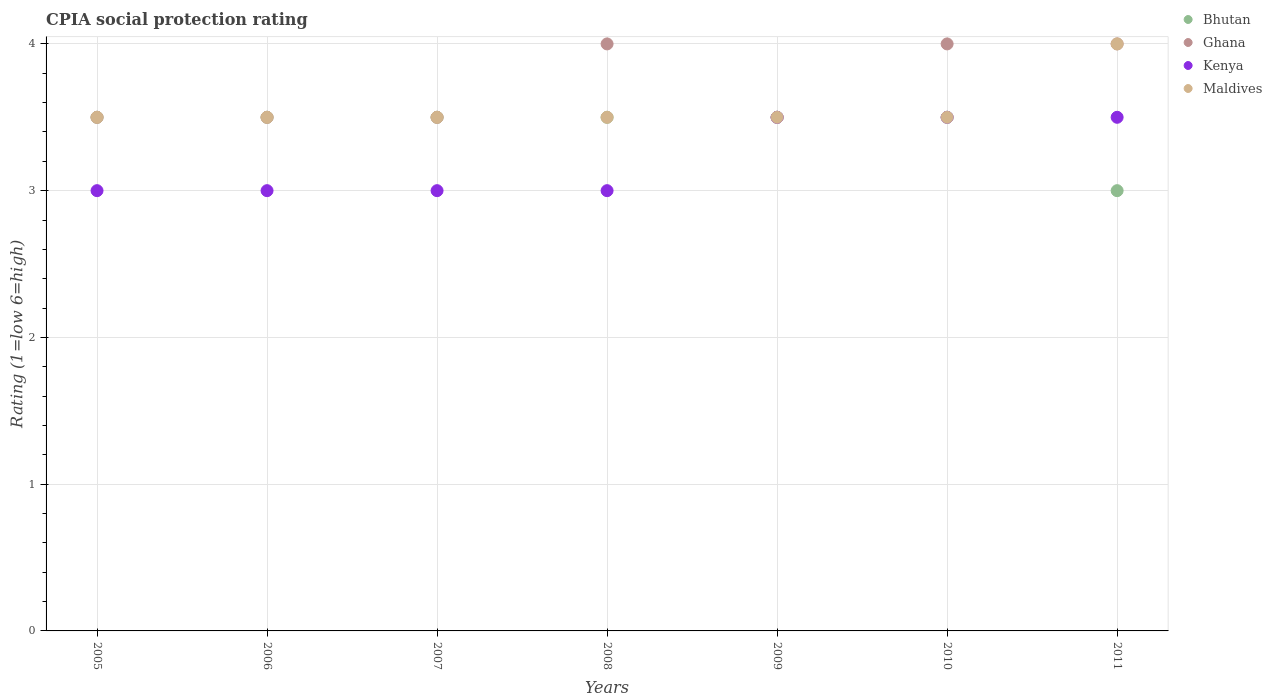What is the CPIA rating in Maldives in 2010?
Make the answer very short. 3.5. Across all years, what is the minimum CPIA rating in Kenya?
Ensure brevity in your answer.  3. What is the total CPIA rating in Maldives in the graph?
Offer a very short reply. 25. What is the average CPIA rating in Kenya per year?
Your answer should be compact. 3.21. What is the ratio of the CPIA rating in Ghana in 2010 to that in 2011?
Ensure brevity in your answer.  1. Is the difference between the CPIA rating in Ghana in 2005 and 2006 greater than the difference between the CPIA rating in Bhutan in 2005 and 2006?
Keep it short and to the point. No. Is the sum of the CPIA rating in Ghana in 2008 and 2009 greater than the maximum CPIA rating in Bhutan across all years?
Your answer should be very brief. Yes. Is it the case that in every year, the sum of the CPIA rating in Maldives and CPIA rating in Kenya  is greater than the CPIA rating in Ghana?
Ensure brevity in your answer.  Yes. Is the CPIA rating in Ghana strictly less than the CPIA rating in Maldives over the years?
Provide a succinct answer. No. What is the difference between two consecutive major ticks on the Y-axis?
Ensure brevity in your answer.  1. Are the values on the major ticks of Y-axis written in scientific E-notation?
Keep it short and to the point. No. Does the graph contain any zero values?
Provide a short and direct response. No. Does the graph contain grids?
Provide a succinct answer. Yes. Where does the legend appear in the graph?
Your response must be concise. Top right. How are the legend labels stacked?
Give a very brief answer. Vertical. What is the title of the graph?
Ensure brevity in your answer.  CPIA social protection rating. Does "Venezuela" appear as one of the legend labels in the graph?
Provide a succinct answer. No. What is the label or title of the X-axis?
Your answer should be very brief. Years. What is the Rating (1=low 6=high) of Bhutan in 2005?
Your answer should be very brief. 3.5. What is the Rating (1=low 6=high) in Ghana in 2005?
Ensure brevity in your answer.  3.5. What is the Rating (1=low 6=high) of Kenya in 2005?
Ensure brevity in your answer.  3. What is the Rating (1=low 6=high) of Maldives in 2005?
Provide a short and direct response. 3.5. What is the Rating (1=low 6=high) of Ghana in 2006?
Offer a terse response. 3.5. What is the Rating (1=low 6=high) in Kenya in 2006?
Provide a short and direct response. 3. What is the Rating (1=low 6=high) in Maldives in 2006?
Keep it short and to the point. 3.5. What is the Rating (1=low 6=high) of Bhutan in 2007?
Ensure brevity in your answer.  3.5. What is the Rating (1=low 6=high) of Ghana in 2007?
Provide a succinct answer. 3.5. What is the Rating (1=low 6=high) of Maldives in 2008?
Offer a very short reply. 3.5. What is the Rating (1=low 6=high) of Bhutan in 2009?
Provide a succinct answer. 3.5. What is the Rating (1=low 6=high) in Ghana in 2009?
Provide a succinct answer. 3.5. What is the Rating (1=low 6=high) of Maldives in 2009?
Your answer should be compact. 3.5. What is the Rating (1=low 6=high) of Bhutan in 2010?
Make the answer very short. 3.5. What is the Rating (1=low 6=high) of Maldives in 2010?
Provide a succinct answer. 3.5. What is the Rating (1=low 6=high) in Ghana in 2011?
Provide a succinct answer. 4. What is the Rating (1=low 6=high) of Kenya in 2011?
Give a very brief answer. 3.5. Across all years, what is the maximum Rating (1=low 6=high) of Ghana?
Offer a very short reply. 4. Across all years, what is the maximum Rating (1=low 6=high) in Kenya?
Your response must be concise. 3.5. Across all years, what is the maximum Rating (1=low 6=high) in Maldives?
Keep it short and to the point. 4. Across all years, what is the minimum Rating (1=low 6=high) in Bhutan?
Your response must be concise. 3. Across all years, what is the minimum Rating (1=low 6=high) in Kenya?
Provide a succinct answer. 3. What is the total Rating (1=low 6=high) of Bhutan in the graph?
Offer a terse response. 24. What is the total Rating (1=low 6=high) in Ghana in the graph?
Keep it short and to the point. 26. What is the total Rating (1=low 6=high) in Kenya in the graph?
Offer a very short reply. 22.5. What is the difference between the Rating (1=low 6=high) of Ghana in 2005 and that in 2006?
Offer a terse response. 0. What is the difference between the Rating (1=low 6=high) of Maldives in 2005 and that in 2006?
Your answer should be compact. 0. What is the difference between the Rating (1=low 6=high) in Bhutan in 2005 and that in 2007?
Ensure brevity in your answer.  0. What is the difference between the Rating (1=low 6=high) of Ghana in 2005 and that in 2007?
Your answer should be very brief. 0. What is the difference between the Rating (1=low 6=high) of Kenya in 2005 and that in 2007?
Offer a very short reply. 0. What is the difference between the Rating (1=low 6=high) of Maldives in 2005 and that in 2007?
Give a very brief answer. 0. What is the difference between the Rating (1=low 6=high) of Ghana in 2005 and that in 2008?
Provide a short and direct response. -0.5. What is the difference between the Rating (1=low 6=high) in Maldives in 2005 and that in 2008?
Make the answer very short. 0. What is the difference between the Rating (1=low 6=high) in Maldives in 2005 and that in 2009?
Your answer should be very brief. 0. What is the difference between the Rating (1=low 6=high) of Bhutan in 2005 and that in 2010?
Your answer should be very brief. 0. What is the difference between the Rating (1=low 6=high) of Ghana in 2005 and that in 2010?
Your response must be concise. -0.5. What is the difference between the Rating (1=low 6=high) of Ghana in 2005 and that in 2011?
Offer a terse response. -0.5. What is the difference between the Rating (1=low 6=high) of Kenya in 2005 and that in 2011?
Keep it short and to the point. -0.5. What is the difference between the Rating (1=low 6=high) of Bhutan in 2006 and that in 2008?
Your response must be concise. 0. What is the difference between the Rating (1=low 6=high) in Kenya in 2006 and that in 2008?
Keep it short and to the point. 0. What is the difference between the Rating (1=low 6=high) in Bhutan in 2006 and that in 2009?
Provide a short and direct response. 0. What is the difference between the Rating (1=low 6=high) of Ghana in 2006 and that in 2009?
Offer a terse response. 0. What is the difference between the Rating (1=low 6=high) of Kenya in 2006 and that in 2009?
Offer a terse response. -0.5. What is the difference between the Rating (1=low 6=high) in Kenya in 2006 and that in 2010?
Offer a terse response. -0.5. What is the difference between the Rating (1=low 6=high) in Kenya in 2006 and that in 2011?
Ensure brevity in your answer.  -0.5. What is the difference between the Rating (1=low 6=high) of Maldives in 2006 and that in 2011?
Provide a short and direct response. -0.5. What is the difference between the Rating (1=low 6=high) in Bhutan in 2007 and that in 2008?
Give a very brief answer. 0. What is the difference between the Rating (1=low 6=high) of Ghana in 2007 and that in 2008?
Make the answer very short. -0.5. What is the difference between the Rating (1=low 6=high) of Bhutan in 2007 and that in 2009?
Your answer should be very brief. 0. What is the difference between the Rating (1=low 6=high) in Kenya in 2007 and that in 2009?
Provide a succinct answer. -0.5. What is the difference between the Rating (1=low 6=high) in Ghana in 2007 and that in 2010?
Keep it short and to the point. -0.5. What is the difference between the Rating (1=low 6=high) in Kenya in 2007 and that in 2010?
Offer a terse response. -0.5. What is the difference between the Rating (1=low 6=high) of Bhutan in 2007 and that in 2011?
Keep it short and to the point. 0.5. What is the difference between the Rating (1=low 6=high) of Kenya in 2007 and that in 2011?
Your answer should be compact. -0.5. What is the difference between the Rating (1=low 6=high) of Bhutan in 2008 and that in 2009?
Provide a succinct answer. 0. What is the difference between the Rating (1=low 6=high) in Kenya in 2008 and that in 2009?
Keep it short and to the point. -0.5. What is the difference between the Rating (1=low 6=high) in Ghana in 2008 and that in 2010?
Provide a short and direct response. 0. What is the difference between the Rating (1=low 6=high) in Maldives in 2009 and that in 2010?
Offer a very short reply. 0. What is the difference between the Rating (1=low 6=high) of Bhutan in 2009 and that in 2011?
Keep it short and to the point. 0.5. What is the difference between the Rating (1=low 6=high) of Kenya in 2009 and that in 2011?
Your answer should be compact. 0. What is the difference between the Rating (1=low 6=high) in Bhutan in 2010 and that in 2011?
Offer a terse response. 0.5. What is the difference between the Rating (1=low 6=high) in Ghana in 2010 and that in 2011?
Keep it short and to the point. 0. What is the difference between the Rating (1=low 6=high) in Kenya in 2010 and that in 2011?
Make the answer very short. 0. What is the difference between the Rating (1=low 6=high) in Bhutan in 2005 and the Rating (1=low 6=high) in Kenya in 2006?
Your answer should be very brief. 0.5. What is the difference between the Rating (1=low 6=high) in Bhutan in 2005 and the Rating (1=low 6=high) in Maldives in 2006?
Provide a short and direct response. 0. What is the difference between the Rating (1=low 6=high) in Ghana in 2005 and the Rating (1=low 6=high) in Kenya in 2006?
Your answer should be compact. 0.5. What is the difference between the Rating (1=low 6=high) of Bhutan in 2005 and the Rating (1=low 6=high) of Ghana in 2007?
Offer a terse response. 0. What is the difference between the Rating (1=low 6=high) of Bhutan in 2005 and the Rating (1=low 6=high) of Kenya in 2007?
Your answer should be compact. 0.5. What is the difference between the Rating (1=low 6=high) of Bhutan in 2005 and the Rating (1=low 6=high) of Maldives in 2007?
Offer a very short reply. 0. What is the difference between the Rating (1=low 6=high) in Bhutan in 2005 and the Rating (1=low 6=high) in Kenya in 2008?
Keep it short and to the point. 0.5. What is the difference between the Rating (1=low 6=high) of Ghana in 2005 and the Rating (1=low 6=high) of Maldives in 2008?
Offer a very short reply. 0. What is the difference between the Rating (1=low 6=high) in Bhutan in 2005 and the Rating (1=low 6=high) in Kenya in 2009?
Ensure brevity in your answer.  0. What is the difference between the Rating (1=low 6=high) of Bhutan in 2005 and the Rating (1=low 6=high) of Maldives in 2009?
Keep it short and to the point. 0. What is the difference between the Rating (1=low 6=high) in Ghana in 2005 and the Rating (1=low 6=high) in Maldives in 2009?
Provide a succinct answer. 0. What is the difference between the Rating (1=low 6=high) in Ghana in 2005 and the Rating (1=low 6=high) in Maldives in 2010?
Your answer should be very brief. 0. What is the difference between the Rating (1=low 6=high) in Kenya in 2005 and the Rating (1=low 6=high) in Maldives in 2010?
Make the answer very short. -0.5. What is the difference between the Rating (1=low 6=high) of Bhutan in 2005 and the Rating (1=low 6=high) of Kenya in 2011?
Make the answer very short. 0. What is the difference between the Rating (1=low 6=high) in Bhutan in 2005 and the Rating (1=low 6=high) in Maldives in 2011?
Offer a very short reply. -0.5. What is the difference between the Rating (1=low 6=high) of Ghana in 2005 and the Rating (1=low 6=high) of Maldives in 2011?
Offer a very short reply. -0.5. What is the difference between the Rating (1=low 6=high) in Kenya in 2005 and the Rating (1=low 6=high) in Maldives in 2011?
Give a very brief answer. -1. What is the difference between the Rating (1=low 6=high) in Kenya in 2006 and the Rating (1=low 6=high) in Maldives in 2007?
Make the answer very short. -0.5. What is the difference between the Rating (1=low 6=high) in Bhutan in 2006 and the Rating (1=low 6=high) in Maldives in 2008?
Keep it short and to the point. 0. What is the difference between the Rating (1=low 6=high) of Kenya in 2006 and the Rating (1=low 6=high) of Maldives in 2008?
Provide a short and direct response. -0.5. What is the difference between the Rating (1=low 6=high) of Bhutan in 2006 and the Rating (1=low 6=high) of Kenya in 2009?
Ensure brevity in your answer.  0. What is the difference between the Rating (1=low 6=high) in Bhutan in 2006 and the Rating (1=low 6=high) in Maldives in 2009?
Your response must be concise. 0. What is the difference between the Rating (1=low 6=high) of Ghana in 2006 and the Rating (1=low 6=high) of Maldives in 2009?
Your response must be concise. 0. What is the difference between the Rating (1=low 6=high) in Kenya in 2006 and the Rating (1=low 6=high) in Maldives in 2009?
Offer a very short reply. -0.5. What is the difference between the Rating (1=low 6=high) in Bhutan in 2006 and the Rating (1=low 6=high) in Ghana in 2010?
Your answer should be very brief. -0.5. What is the difference between the Rating (1=low 6=high) of Bhutan in 2006 and the Rating (1=low 6=high) of Maldives in 2010?
Provide a succinct answer. 0. What is the difference between the Rating (1=low 6=high) in Ghana in 2006 and the Rating (1=low 6=high) in Kenya in 2010?
Offer a very short reply. 0. What is the difference between the Rating (1=low 6=high) in Ghana in 2006 and the Rating (1=low 6=high) in Maldives in 2010?
Your answer should be compact. 0. What is the difference between the Rating (1=low 6=high) of Kenya in 2006 and the Rating (1=low 6=high) of Maldives in 2010?
Offer a very short reply. -0.5. What is the difference between the Rating (1=low 6=high) in Bhutan in 2006 and the Rating (1=low 6=high) in Ghana in 2011?
Your answer should be very brief. -0.5. What is the difference between the Rating (1=low 6=high) in Bhutan in 2006 and the Rating (1=low 6=high) in Kenya in 2011?
Ensure brevity in your answer.  0. What is the difference between the Rating (1=low 6=high) in Bhutan in 2006 and the Rating (1=low 6=high) in Maldives in 2011?
Give a very brief answer. -0.5. What is the difference between the Rating (1=low 6=high) in Ghana in 2006 and the Rating (1=low 6=high) in Maldives in 2011?
Your answer should be compact. -0.5. What is the difference between the Rating (1=low 6=high) in Kenya in 2006 and the Rating (1=low 6=high) in Maldives in 2011?
Your answer should be very brief. -1. What is the difference between the Rating (1=low 6=high) in Bhutan in 2007 and the Rating (1=low 6=high) in Maldives in 2008?
Your response must be concise. 0. What is the difference between the Rating (1=low 6=high) in Kenya in 2007 and the Rating (1=low 6=high) in Maldives in 2008?
Offer a terse response. -0.5. What is the difference between the Rating (1=low 6=high) in Bhutan in 2007 and the Rating (1=low 6=high) in Ghana in 2009?
Give a very brief answer. 0. What is the difference between the Rating (1=low 6=high) of Bhutan in 2007 and the Rating (1=low 6=high) of Kenya in 2009?
Provide a succinct answer. 0. What is the difference between the Rating (1=low 6=high) in Bhutan in 2007 and the Rating (1=low 6=high) in Ghana in 2010?
Provide a short and direct response. -0.5. What is the difference between the Rating (1=low 6=high) of Bhutan in 2007 and the Rating (1=low 6=high) of Kenya in 2010?
Offer a very short reply. 0. What is the difference between the Rating (1=low 6=high) of Bhutan in 2007 and the Rating (1=low 6=high) of Maldives in 2010?
Offer a very short reply. 0. What is the difference between the Rating (1=low 6=high) in Bhutan in 2007 and the Rating (1=low 6=high) in Ghana in 2011?
Offer a very short reply. -0.5. What is the difference between the Rating (1=low 6=high) in Kenya in 2007 and the Rating (1=low 6=high) in Maldives in 2011?
Your answer should be very brief. -1. What is the difference between the Rating (1=low 6=high) of Bhutan in 2008 and the Rating (1=low 6=high) of Ghana in 2009?
Give a very brief answer. 0. What is the difference between the Rating (1=low 6=high) in Bhutan in 2008 and the Rating (1=low 6=high) in Kenya in 2009?
Give a very brief answer. 0. What is the difference between the Rating (1=low 6=high) of Bhutan in 2008 and the Rating (1=low 6=high) of Ghana in 2010?
Make the answer very short. -0.5. What is the difference between the Rating (1=low 6=high) of Bhutan in 2008 and the Rating (1=low 6=high) of Maldives in 2010?
Your answer should be compact. 0. What is the difference between the Rating (1=low 6=high) of Ghana in 2008 and the Rating (1=low 6=high) of Maldives in 2010?
Your response must be concise. 0.5. What is the difference between the Rating (1=low 6=high) in Kenya in 2008 and the Rating (1=low 6=high) in Maldives in 2010?
Offer a terse response. -0.5. What is the difference between the Rating (1=low 6=high) in Bhutan in 2008 and the Rating (1=low 6=high) in Maldives in 2011?
Your response must be concise. -0.5. What is the difference between the Rating (1=low 6=high) in Ghana in 2008 and the Rating (1=low 6=high) in Kenya in 2011?
Your answer should be compact. 0.5. What is the difference between the Rating (1=low 6=high) in Ghana in 2008 and the Rating (1=low 6=high) in Maldives in 2011?
Your answer should be compact. 0. What is the difference between the Rating (1=low 6=high) in Kenya in 2008 and the Rating (1=low 6=high) in Maldives in 2011?
Provide a succinct answer. -1. What is the difference between the Rating (1=low 6=high) of Bhutan in 2009 and the Rating (1=low 6=high) of Kenya in 2010?
Keep it short and to the point. 0. What is the difference between the Rating (1=low 6=high) of Bhutan in 2009 and the Rating (1=low 6=high) of Maldives in 2010?
Your answer should be compact. 0. What is the difference between the Rating (1=low 6=high) in Ghana in 2009 and the Rating (1=low 6=high) in Kenya in 2010?
Keep it short and to the point. 0. What is the difference between the Rating (1=low 6=high) in Ghana in 2009 and the Rating (1=low 6=high) in Maldives in 2010?
Offer a very short reply. 0. What is the difference between the Rating (1=low 6=high) of Kenya in 2009 and the Rating (1=low 6=high) of Maldives in 2010?
Give a very brief answer. 0. What is the difference between the Rating (1=low 6=high) in Bhutan in 2010 and the Rating (1=low 6=high) in Maldives in 2011?
Offer a terse response. -0.5. What is the difference between the Rating (1=low 6=high) of Kenya in 2010 and the Rating (1=low 6=high) of Maldives in 2011?
Provide a succinct answer. -0.5. What is the average Rating (1=low 6=high) of Bhutan per year?
Offer a very short reply. 3.43. What is the average Rating (1=low 6=high) in Ghana per year?
Keep it short and to the point. 3.71. What is the average Rating (1=low 6=high) of Kenya per year?
Provide a short and direct response. 3.21. What is the average Rating (1=low 6=high) of Maldives per year?
Your answer should be compact. 3.57. In the year 2005, what is the difference between the Rating (1=low 6=high) of Bhutan and Rating (1=low 6=high) of Kenya?
Offer a very short reply. 0.5. In the year 2005, what is the difference between the Rating (1=low 6=high) of Bhutan and Rating (1=low 6=high) of Maldives?
Make the answer very short. 0. In the year 2005, what is the difference between the Rating (1=low 6=high) in Ghana and Rating (1=low 6=high) in Kenya?
Your response must be concise. 0.5. In the year 2005, what is the difference between the Rating (1=low 6=high) in Ghana and Rating (1=low 6=high) in Maldives?
Keep it short and to the point. 0. In the year 2006, what is the difference between the Rating (1=low 6=high) in Ghana and Rating (1=low 6=high) in Maldives?
Provide a succinct answer. 0. In the year 2007, what is the difference between the Rating (1=low 6=high) in Bhutan and Rating (1=low 6=high) in Ghana?
Your answer should be very brief. 0. In the year 2007, what is the difference between the Rating (1=low 6=high) of Ghana and Rating (1=low 6=high) of Kenya?
Your answer should be very brief. 0.5. In the year 2007, what is the difference between the Rating (1=low 6=high) of Kenya and Rating (1=low 6=high) of Maldives?
Your response must be concise. -0.5. In the year 2008, what is the difference between the Rating (1=low 6=high) of Bhutan and Rating (1=low 6=high) of Ghana?
Your response must be concise. -0.5. In the year 2008, what is the difference between the Rating (1=low 6=high) of Bhutan and Rating (1=low 6=high) of Maldives?
Provide a succinct answer. 0. In the year 2008, what is the difference between the Rating (1=low 6=high) in Ghana and Rating (1=low 6=high) in Kenya?
Offer a terse response. 1. In the year 2008, what is the difference between the Rating (1=low 6=high) of Ghana and Rating (1=low 6=high) of Maldives?
Make the answer very short. 0.5. In the year 2009, what is the difference between the Rating (1=low 6=high) of Bhutan and Rating (1=low 6=high) of Ghana?
Offer a very short reply. 0. In the year 2009, what is the difference between the Rating (1=low 6=high) of Bhutan and Rating (1=low 6=high) of Maldives?
Make the answer very short. 0. In the year 2009, what is the difference between the Rating (1=low 6=high) of Ghana and Rating (1=low 6=high) of Maldives?
Make the answer very short. 0. In the year 2009, what is the difference between the Rating (1=low 6=high) of Kenya and Rating (1=low 6=high) of Maldives?
Your answer should be very brief. 0. In the year 2010, what is the difference between the Rating (1=low 6=high) in Bhutan and Rating (1=low 6=high) in Maldives?
Provide a succinct answer. 0. In the year 2010, what is the difference between the Rating (1=low 6=high) of Ghana and Rating (1=low 6=high) of Kenya?
Provide a short and direct response. 0.5. In the year 2011, what is the difference between the Rating (1=low 6=high) in Bhutan and Rating (1=low 6=high) in Kenya?
Make the answer very short. -0.5. In the year 2011, what is the difference between the Rating (1=low 6=high) of Bhutan and Rating (1=low 6=high) of Maldives?
Keep it short and to the point. -1. In the year 2011, what is the difference between the Rating (1=low 6=high) of Ghana and Rating (1=low 6=high) of Kenya?
Your answer should be compact. 0.5. In the year 2011, what is the difference between the Rating (1=low 6=high) of Ghana and Rating (1=low 6=high) of Maldives?
Your response must be concise. 0. What is the ratio of the Rating (1=low 6=high) of Bhutan in 2005 to that in 2006?
Ensure brevity in your answer.  1. What is the ratio of the Rating (1=low 6=high) of Ghana in 2005 to that in 2006?
Offer a terse response. 1. What is the ratio of the Rating (1=low 6=high) of Bhutan in 2005 to that in 2007?
Provide a short and direct response. 1. What is the ratio of the Rating (1=low 6=high) in Ghana in 2005 to that in 2007?
Make the answer very short. 1. What is the ratio of the Rating (1=low 6=high) in Kenya in 2005 to that in 2007?
Your answer should be compact. 1. What is the ratio of the Rating (1=low 6=high) in Ghana in 2005 to that in 2008?
Ensure brevity in your answer.  0.88. What is the ratio of the Rating (1=low 6=high) of Maldives in 2005 to that in 2008?
Offer a very short reply. 1. What is the ratio of the Rating (1=low 6=high) of Kenya in 2005 to that in 2009?
Make the answer very short. 0.86. What is the ratio of the Rating (1=low 6=high) in Maldives in 2005 to that in 2009?
Your response must be concise. 1. What is the ratio of the Rating (1=low 6=high) in Bhutan in 2005 to that in 2010?
Your response must be concise. 1. What is the ratio of the Rating (1=low 6=high) in Maldives in 2005 to that in 2010?
Offer a very short reply. 1. What is the ratio of the Rating (1=low 6=high) in Maldives in 2005 to that in 2011?
Make the answer very short. 0.88. What is the ratio of the Rating (1=low 6=high) in Bhutan in 2006 to that in 2007?
Ensure brevity in your answer.  1. What is the ratio of the Rating (1=low 6=high) of Kenya in 2006 to that in 2007?
Make the answer very short. 1. What is the ratio of the Rating (1=low 6=high) of Maldives in 2006 to that in 2007?
Keep it short and to the point. 1. What is the ratio of the Rating (1=low 6=high) of Bhutan in 2006 to that in 2008?
Give a very brief answer. 1. What is the ratio of the Rating (1=low 6=high) in Ghana in 2006 to that in 2008?
Your response must be concise. 0.88. What is the ratio of the Rating (1=low 6=high) in Maldives in 2006 to that in 2008?
Give a very brief answer. 1. What is the ratio of the Rating (1=low 6=high) of Kenya in 2006 to that in 2009?
Your answer should be compact. 0.86. What is the ratio of the Rating (1=low 6=high) in Bhutan in 2006 to that in 2010?
Provide a succinct answer. 1. What is the ratio of the Rating (1=low 6=high) in Kenya in 2006 to that in 2010?
Offer a terse response. 0.86. What is the ratio of the Rating (1=low 6=high) in Bhutan in 2006 to that in 2011?
Your answer should be very brief. 1.17. What is the ratio of the Rating (1=low 6=high) of Ghana in 2006 to that in 2011?
Provide a succinct answer. 0.88. What is the ratio of the Rating (1=low 6=high) of Kenya in 2006 to that in 2011?
Offer a very short reply. 0.86. What is the ratio of the Rating (1=low 6=high) in Maldives in 2006 to that in 2011?
Provide a short and direct response. 0.88. What is the ratio of the Rating (1=low 6=high) in Maldives in 2007 to that in 2008?
Provide a succinct answer. 1. What is the ratio of the Rating (1=low 6=high) in Ghana in 2007 to that in 2009?
Your answer should be very brief. 1. What is the ratio of the Rating (1=low 6=high) of Maldives in 2007 to that in 2009?
Your answer should be compact. 1. What is the ratio of the Rating (1=low 6=high) of Kenya in 2007 to that in 2010?
Ensure brevity in your answer.  0.86. What is the ratio of the Rating (1=low 6=high) in Maldives in 2007 to that in 2010?
Ensure brevity in your answer.  1. What is the ratio of the Rating (1=low 6=high) in Ghana in 2007 to that in 2011?
Your answer should be compact. 0.88. What is the ratio of the Rating (1=low 6=high) of Maldives in 2007 to that in 2011?
Provide a succinct answer. 0.88. What is the ratio of the Rating (1=low 6=high) of Maldives in 2008 to that in 2009?
Make the answer very short. 1. What is the ratio of the Rating (1=low 6=high) in Kenya in 2008 to that in 2010?
Make the answer very short. 0.86. What is the ratio of the Rating (1=low 6=high) of Bhutan in 2008 to that in 2011?
Your answer should be compact. 1.17. What is the ratio of the Rating (1=low 6=high) of Ghana in 2008 to that in 2011?
Make the answer very short. 1. What is the ratio of the Rating (1=low 6=high) in Kenya in 2008 to that in 2011?
Provide a short and direct response. 0.86. What is the ratio of the Rating (1=low 6=high) in Maldives in 2008 to that in 2011?
Provide a short and direct response. 0.88. What is the ratio of the Rating (1=low 6=high) in Bhutan in 2009 to that in 2010?
Your answer should be very brief. 1. What is the ratio of the Rating (1=low 6=high) in Ghana in 2009 to that in 2010?
Give a very brief answer. 0.88. What is the ratio of the Rating (1=low 6=high) of Maldives in 2009 to that in 2010?
Your answer should be compact. 1. What is the ratio of the Rating (1=low 6=high) in Ghana in 2009 to that in 2011?
Offer a very short reply. 0.88. What is the ratio of the Rating (1=low 6=high) in Maldives in 2009 to that in 2011?
Provide a succinct answer. 0.88. What is the ratio of the Rating (1=low 6=high) of Ghana in 2010 to that in 2011?
Keep it short and to the point. 1. What is the ratio of the Rating (1=low 6=high) of Maldives in 2010 to that in 2011?
Your answer should be very brief. 0.88. What is the difference between the highest and the second highest Rating (1=low 6=high) in Bhutan?
Your response must be concise. 0. What is the difference between the highest and the second highest Rating (1=low 6=high) in Ghana?
Your answer should be very brief. 0. What is the difference between the highest and the second highest Rating (1=low 6=high) of Kenya?
Your response must be concise. 0. What is the difference between the highest and the second highest Rating (1=low 6=high) in Maldives?
Keep it short and to the point. 0.5. What is the difference between the highest and the lowest Rating (1=low 6=high) in Bhutan?
Ensure brevity in your answer.  0.5. What is the difference between the highest and the lowest Rating (1=low 6=high) in Maldives?
Give a very brief answer. 0.5. 